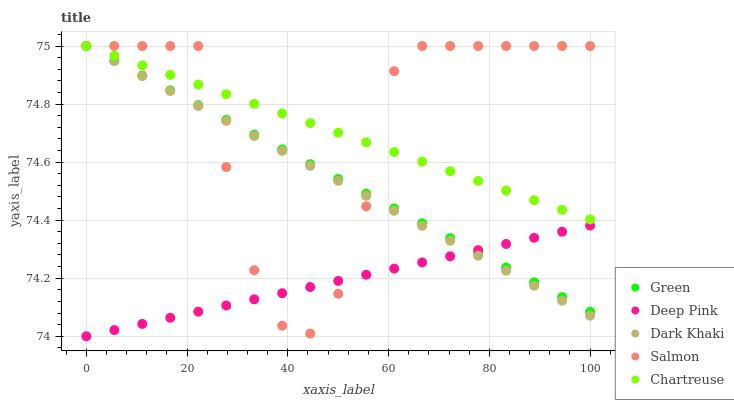Does Deep Pink have the minimum area under the curve?
Answer yes or no. Yes. Does Salmon have the maximum area under the curve?
Answer yes or no. Yes. Does Chartreuse have the minimum area under the curve?
Answer yes or no. No. Does Chartreuse have the maximum area under the curve?
Answer yes or no. No. Is Chartreuse the smoothest?
Answer yes or no. Yes. Is Salmon the roughest?
Answer yes or no. Yes. Is Salmon the smoothest?
Answer yes or no. No. Is Chartreuse the roughest?
Answer yes or no. No. Does Deep Pink have the lowest value?
Answer yes or no. Yes. Does Salmon have the lowest value?
Answer yes or no. No. Does Green have the highest value?
Answer yes or no. Yes. Does Deep Pink have the highest value?
Answer yes or no. No. Is Deep Pink less than Chartreuse?
Answer yes or no. Yes. Is Chartreuse greater than Deep Pink?
Answer yes or no. Yes. Does Salmon intersect Dark Khaki?
Answer yes or no. Yes. Is Salmon less than Dark Khaki?
Answer yes or no. No. Is Salmon greater than Dark Khaki?
Answer yes or no. No. Does Deep Pink intersect Chartreuse?
Answer yes or no. No. 